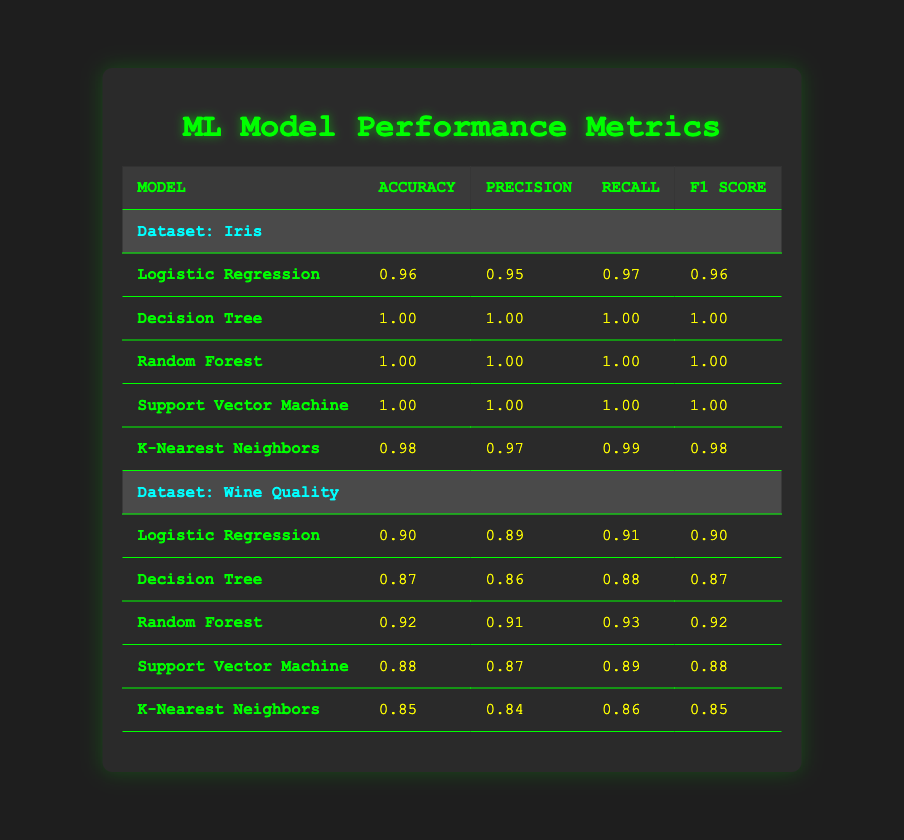What is the accuracy of the Decision Tree model on the Iris dataset? From the table, we can locate the section for the Iris dataset and find the row for the Decision Tree model. In that row, the accuracy value is listed as 1.00.
Answer: 1.00 Which model has the highest f1 score on the Wine Quality dataset? In the Wine Quality section of the table, we compare the f1 scores of all models. The model with the highest f1 score is the Random Forest, with a value of 0.92.
Answer: Random Forest Is the Recall of the K-Nearest Neighbors model on the Iris dataset higher than that on the Wine Quality dataset? Looking at the table, the Recall for the K-Nearest Neighbors on the Iris dataset is 0.99, whereas on the Wine Quality dataset, it is 0.86. Since 0.99 > 0.86, the statement is true.
Answer: Yes What is the average accuracy of all models on the Wine Quality dataset? The accuracies on the Wine Quality dataset are 0.90, 0.87, 0.92, 0.88, and 0.85. Summing these gives 4.42. Dividing by the number of models (5) gives an average of 4.42 / 5 = 0.884.
Answer: 0.884 Is there a model that achieved perfect scores across all metrics on the Iris dataset? By examining the results for all models on the Iris dataset, we note that Decision Tree, Random Forest, and Support Vector Machine each have accuracy, precision, recall, and f1 score values of 1.00, indicating they achieved perfect scores.
Answer: Yes Which model has consistently lower performance on both datasets? By closely analyzing the values, the K-Nearest Neighbors model has the lowest performance relative to the others on both datasets, with accuracy values of 0.98 for Iris and 0.85 for Wine Quality, which are lower compared to other models.
Answer: K-Nearest Neighbors What is the difference in accuracy between the best and worst performing model on the Iris dataset? The best performance on the Iris dataset is from the Decision Tree, Random Forest, and Support Vector Machine, all with 1.00 accuracy. The worst performance is from Logistic Regression with 0.96 accuracy. Therefore, the difference is 1.00 - 0.96 = 0.04.
Answer: 0.04 